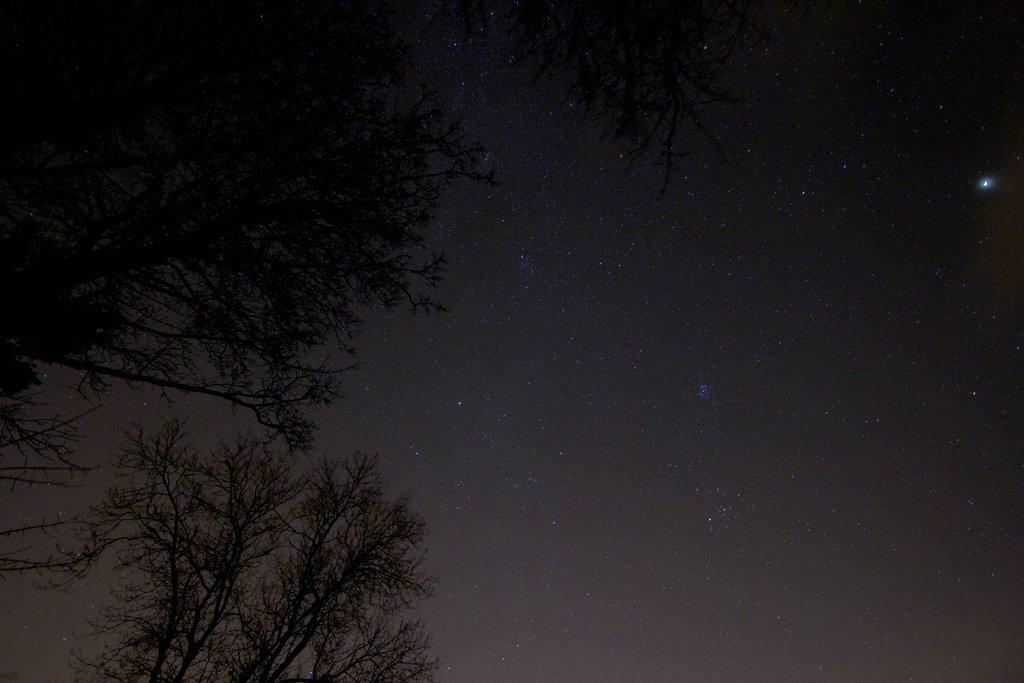What type of vegetation can be seen in the image? There are trees in the image. What can be seen in the sky in the image? Stars are visible in the sky in the image. How many girls are playing on the swing in the image? There are no girls or swings present in the image. What type of pollution can be seen in the image? There is no pollution visible in the image; it features trees and stars in the sky. 